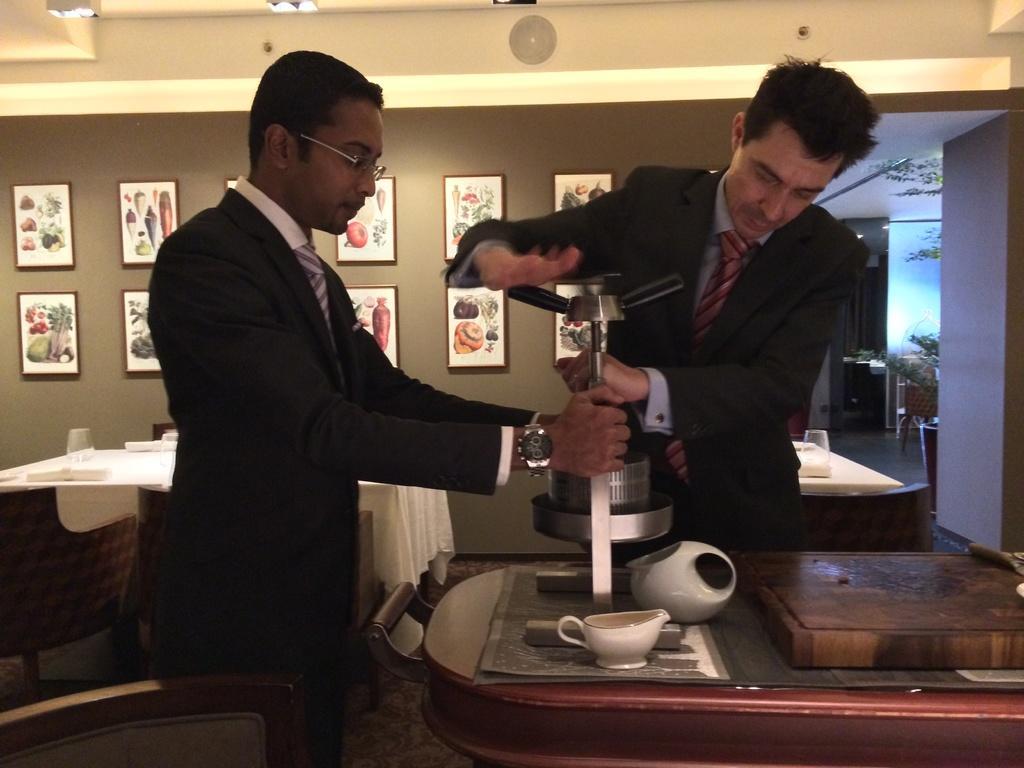Can you describe this image briefly? This image consists of two men wearing black suit and shirt. They are holding a machine. At the bottom, there is a floor. In the background, there is a wall to which many frames are fixed. 